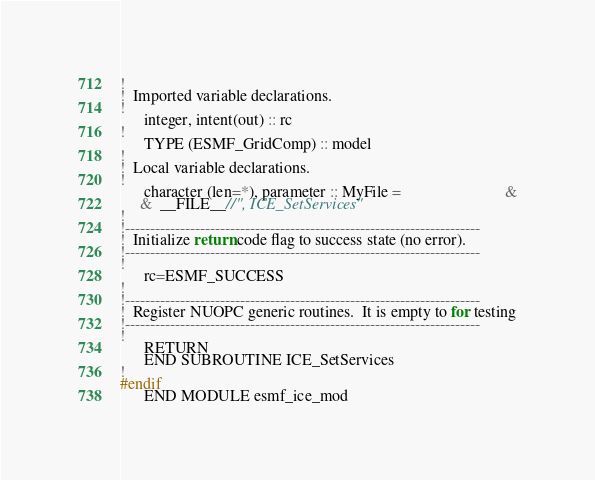Convert code to text. <code><loc_0><loc_0><loc_500><loc_500><_C_>!
!  Imported variable declarations.
!
      integer, intent(out) :: rc
!
      TYPE (ESMF_GridComp) :: model
!
!  Local variable declarations.
!
      character (len=*), parameter :: MyFile =                          &
     &  __FILE__//", ICE_SetServices"
!
!-----------------------------------------------------------------------
!  Initialize return code flag to success state (no error).
!-----------------------------------------------------------------------
!
      rc=ESMF_SUCCESS
!
!-----------------------------------------------------------------------
!  Register NUOPC generic routines.  It is empty to for testing
!-----------------------------------------------------------------------
!
      RETURN
      END SUBROUTINE ICE_SetServices
!
#endif
      END MODULE esmf_ice_mod


</code> 